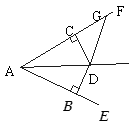As shown in the figure, it is known that DB perpendicular to AE at B, DC perpendicular to AF at C, and DB = DC, angle BAC = 40.0, angle ADG = 130.0. What is angle DGF? Given the constraints where DB is perpendicular to AE and DC is perpendicular to AF, and considering that DB equals DC, triangle ADB is congruent to triangle ADC by SAS (Side-Angle-Side) congruency. This congruence implies that angle BAD is equal to angle CAD. Since angle BAC is 40°, each of angles BAD and CAD is 20°. In triangle ADG, angle ADG is given as 130°. The sum of angles in any triangle is 180°, which means angle AGD and angle ADG sum up to 50°. Therefore, considering the straight line formed at point D through points A and G, angle DGF, which is supplementary to angle AGD, equals 20° + 130° = 150°. Therefore, angle DGF is 150°. 